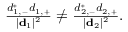Convert formula to latex. <formula><loc_0><loc_0><loc_500><loc_500>\begin{array} { r } { \frac { d _ { 1 , - } ^ { * } d _ { 1 , + } } { | { d } _ { 1 } | ^ { 2 } } \ne \frac { d _ { 2 , - } ^ { * } d _ { 2 , + } } { | { d } _ { 2 } | ^ { 2 } } . } \end{array}</formula> 